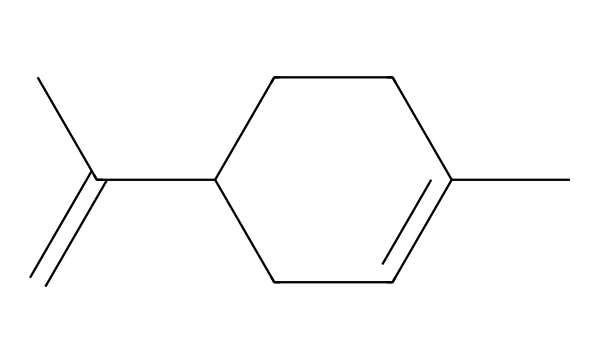How many carbon atoms are in the structure? By examining the SMILES representation, I can count the number of carbon atoms denoted by "C". There are 10 carbon atoms total in this molecule.
Answer: 10 What type of compound is limonene classified as? Limonene is classified as a cyclic monoterpene due to its ring structure and being composed of 10 carbon atoms.
Answer: cyclic monoterpene How many double bonds are in limonene? By analyzing the structure, I can identify two double bonds indicated by the "C=C" portion of the SMILES.
Answer: 2 What functional group is present in limonene? In the structure, there are no specific functional groups like -OH or -COOH; however, limonene has a double bond which classifies it as an alkene.
Answer: alkene What does the structure imply about limonene's scent? The specific arrangement of carbon atoms and double bonds contributes to the volatile nature and fragrant qualities of limonene, which are characteristic of citrus scents.
Answer: citrus scent 